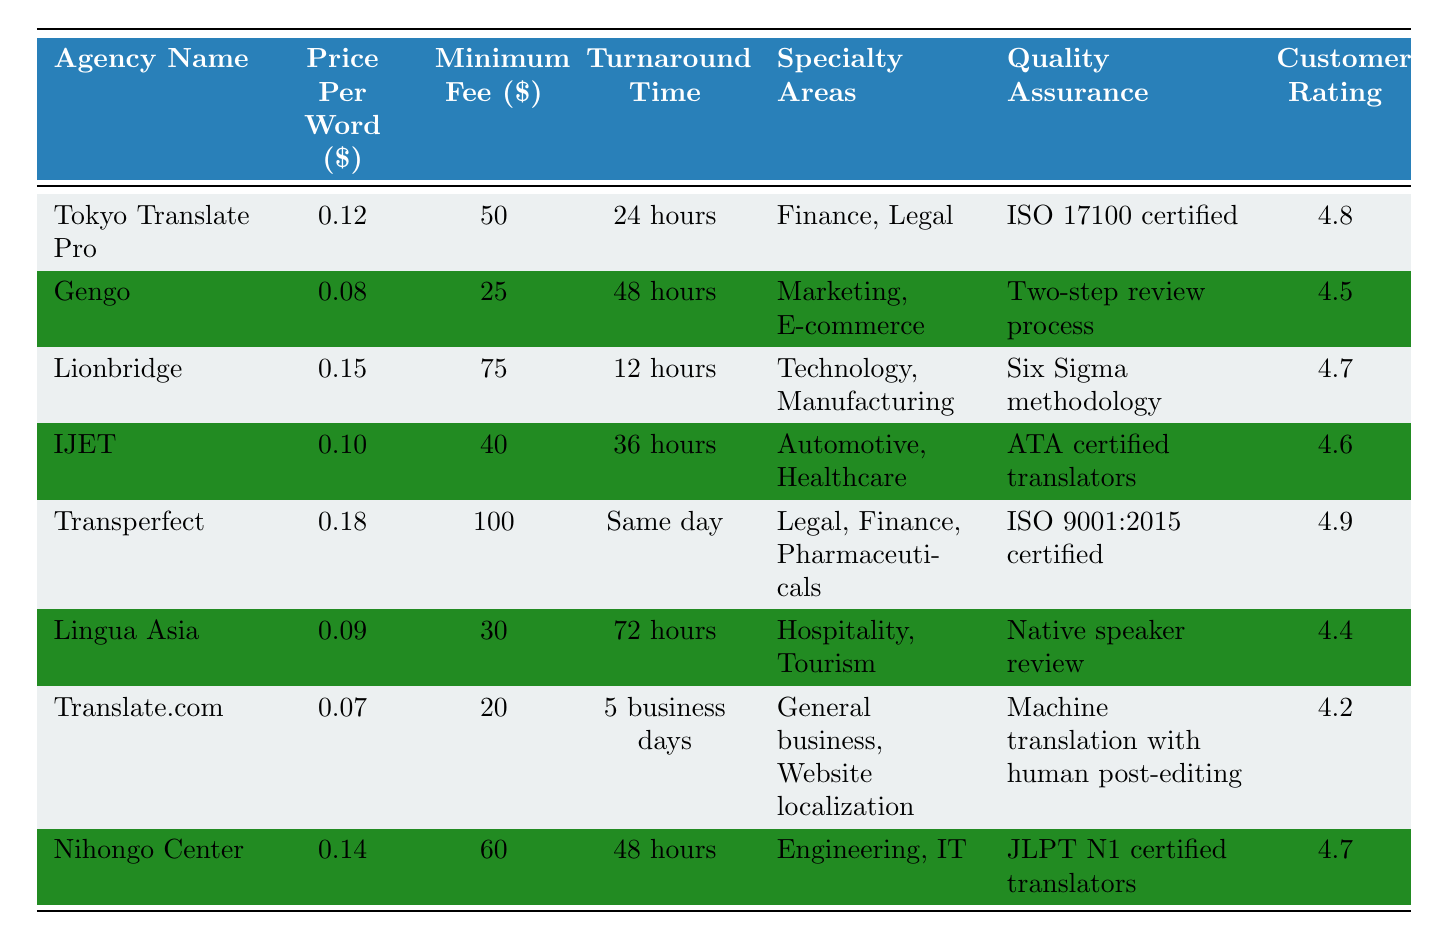What is the minimum fee charged by Gengo? The table states Gengo's minimum fee is $25.
Answer: 25 Which agency has the highest customer rating? The customer ratings for each agency are listed in the table. Transperfect has the highest rating at 4.9.
Answer: Transperfect What is the difference in price per word between Tokyo Translate Pro and Translate.com? Tokyo Translate Pro charges $0.12 per word, while Translate.com charges $0.07 per word. The difference is $0.12 - $0.07 = $0.05.
Answer: 0.05 What is the combined minimum fee of Lionbridge and Nihongo Center? Lionbridge has a minimum fee of $75, and Nihongo Center has a minimum fee of $60. Summing these fees gives $75 + $60 = $135.
Answer: 135 Is the turnaround time for Transperfect shorter than for IJET? The turnaround time for Transperfect is "Same day" and for IJET it is "36 hours." Since "Same day" is shorter than "36 hours," this statement is true.
Answer: Yes Which agencies specialize in legal documents? Looking at the specialty areas, Tokyo Translate Pro and Transperfect both list "Legal" as a specialty.
Answer: Tokyo Translate Pro and Transperfect What is the average price per word for all agencies listed? To find the average, sum all price per word values: 0.12 + 0.08 + 0.15 + 0.10 + 0.18 + 0.09 + 0.07 + 0.14 = 0.93. Then divide by the number of agencies (8): 0.93 / 8 = 0.11625, rounded to four decimal places gives 0.1163.
Answer: 0.1163 Which agency offers the fastest turnaround time? Reviewing the turnaround times, Lionbridge has 12 hours, which is the shortest compared to the others.
Answer: Lionbridge Are there any agencies with a customer rating below 4.5? Translate.com has a customer rating of 4.2, which is lower than 4.5, making this statement true.
Answer: Yes What is the total cost of translating 1,000 words using Lingua Asia? Lingua Asia charges $0.09 per word, so for 1,000 words it would be 1,000 * 0.09 = $90. This fee is above the minimum fee of $30, so the total charge is $90.
Answer: 90 Which agency has a quality assurance process that includes a review by native speakers? According to the table, Lingua Asia has a quality assurance process that includes a native speaker review.
Answer: Lingua Asia 